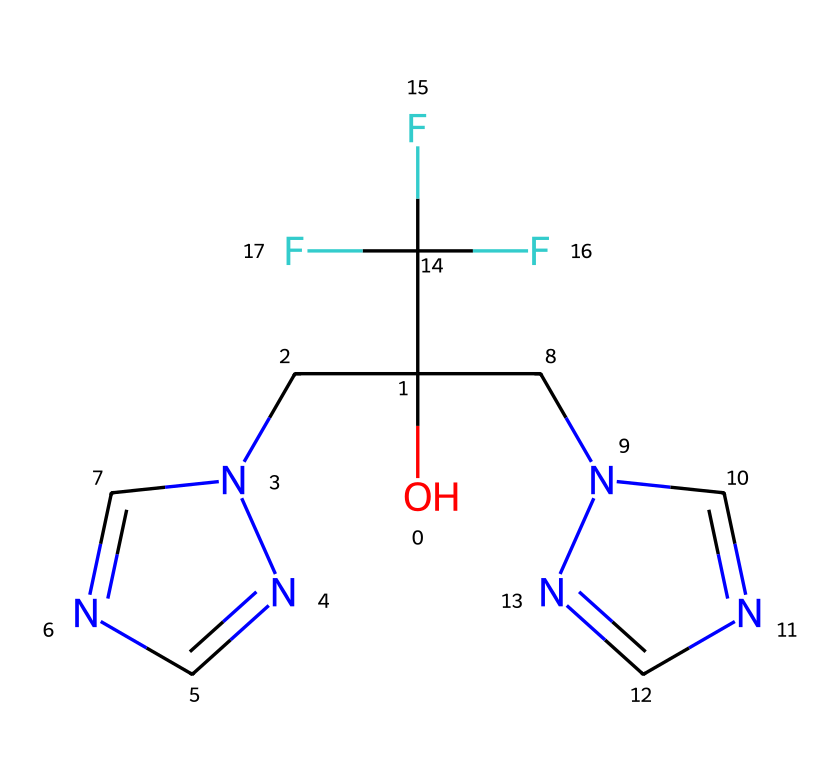What is the chemical name of this compound? The SMILES representation corresponds to a chemical with the structure typical of antifungal medications, specifically fluconazole. SMILES encodes both the atom types and their connectivity, leading to the identification.
Answer: fluconazole How many nitrogen atoms are present? By analyzing the SMILES notation, we can count the nitrogen atoms represented, which are crucial in the structure as they usually indicate the presence of heterocyclic compounds. There are four nitrogen atoms in the structure.
Answer: four What is the molecular formula of fluconazole? To find the molecular formula, we need to identify the constituent atoms from the SMILES. Counting the number of carbon (C), hydrogen (H), nitrogen (N), and oxygen (O) atoms gives us C13H12F2N6O.
Answer: C13H12F2N6O What type of bonds are predominantly present in fluconazole? Examining the structure, we see that fluconazole features both single and double bonds. The presence of nitrogen rings and carbon atoms indicates the common covalent bonds found in organic molecules.
Answer: covalent Does fluconazole have a fluorine substituent? The SMILES notation includes a part that indicates the presence of fluorine atoms attached to carbon atoms. This identifies its use in enhancing bioactivity and solubility in the pharmaceutical context.
Answer: yes What is the functional group represented in fluconazole? The structure includes an OH group, which is indicative of alcohols. This functional group affects both the solubility and reactivity of the molecule in biological systems.
Answer: alcohol What role does fluconazole play in healthcare? Understanding the context, fluconazole is an antifungal medication used to treat infections by inhibiting the synthesis of ergosterol, a critical component in fungal cell membranes.
Answer: antifungal 